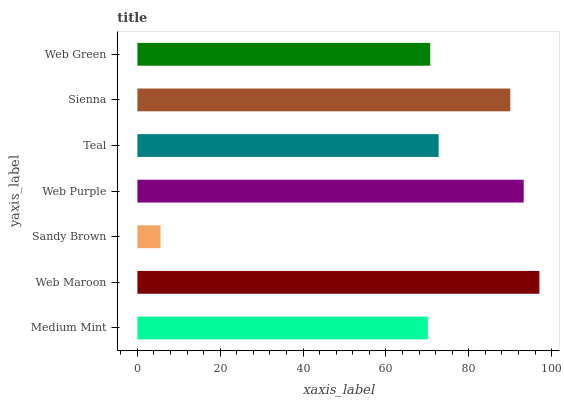Is Sandy Brown the minimum?
Answer yes or no. Yes. Is Web Maroon the maximum?
Answer yes or no. Yes. Is Web Maroon the minimum?
Answer yes or no. No. Is Sandy Brown the maximum?
Answer yes or no. No. Is Web Maroon greater than Sandy Brown?
Answer yes or no. Yes. Is Sandy Brown less than Web Maroon?
Answer yes or no. Yes. Is Sandy Brown greater than Web Maroon?
Answer yes or no. No. Is Web Maroon less than Sandy Brown?
Answer yes or no. No. Is Teal the high median?
Answer yes or no. Yes. Is Teal the low median?
Answer yes or no. Yes. Is Sandy Brown the high median?
Answer yes or no. No. Is Web Maroon the low median?
Answer yes or no. No. 